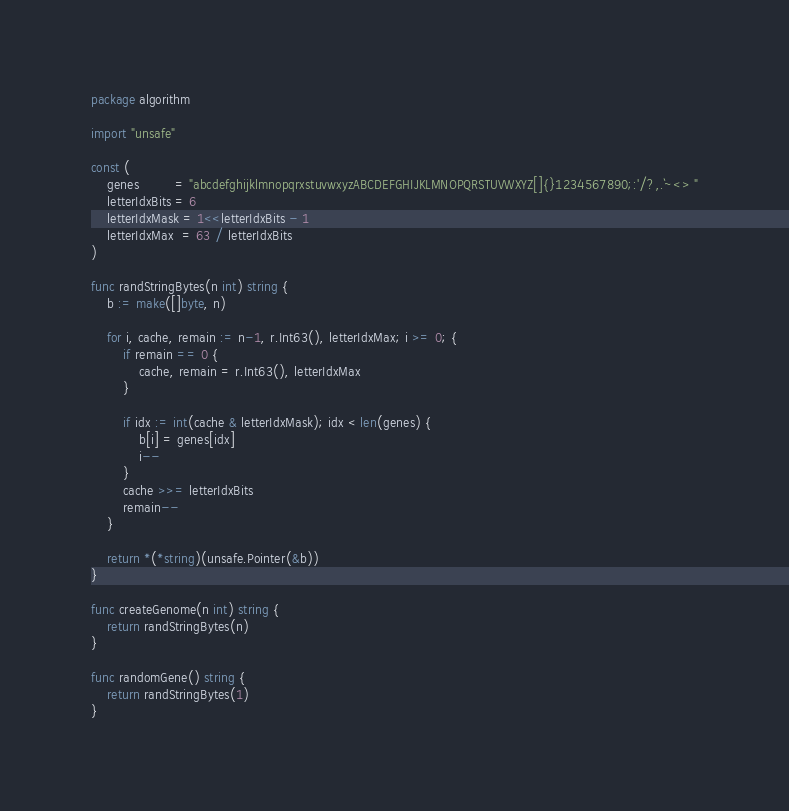Convert code to text. <code><loc_0><loc_0><loc_500><loc_500><_Go_>package algorithm

import "unsafe"

const (
	genes         = "abcdefghijklmnopqrxstuvwxyzABCDEFGHIJKLMNOPQRSTUVWXYZ[]{}1234567890;:'/?,.`~<> "
	letterIdxBits = 6
	letterIdxMask = 1<<letterIdxBits - 1
	letterIdxMax  = 63 / letterIdxBits
)

func randStringBytes(n int) string {
	b := make([]byte, n)

	for i, cache, remain := n-1, r.Int63(), letterIdxMax; i >= 0; {
		if remain == 0 {
			cache, remain = r.Int63(), letterIdxMax
		}

		if idx := int(cache & letterIdxMask); idx < len(genes) {
			b[i] = genes[idx]
			i--
		}
		cache >>= letterIdxBits
		remain--
	}

	return *(*string)(unsafe.Pointer(&b))
}

func createGenome(n int) string {
	return randStringBytes(n)
}

func randomGene() string {
	return randStringBytes(1)
}
</code> 